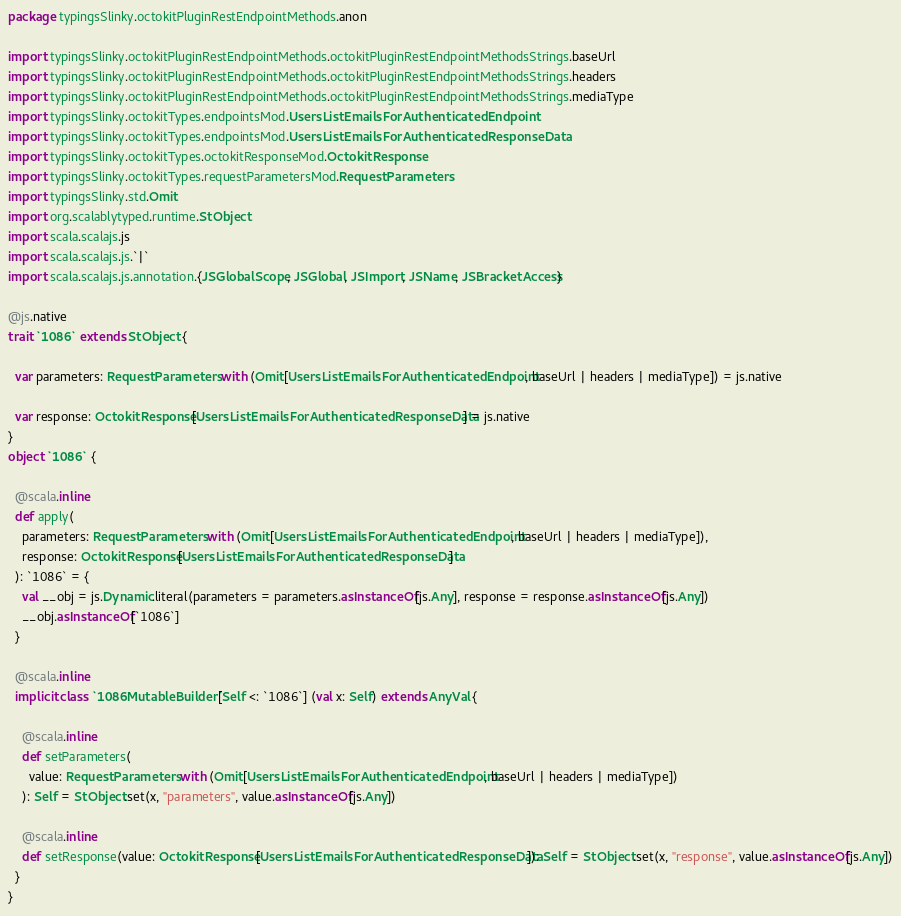Convert code to text. <code><loc_0><loc_0><loc_500><loc_500><_Scala_>package typingsSlinky.octokitPluginRestEndpointMethods.anon

import typingsSlinky.octokitPluginRestEndpointMethods.octokitPluginRestEndpointMethodsStrings.baseUrl
import typingsSlinky.octokitPluginRestEndpointMethods.octokitPluginRestEndpointMethodsStrings.headers
import typingsSlinky.octokitPluginRestEndpointMethods.octokitPluginRestEndpointMethodsStrings.mediaType
import typingsSlinky.octokitTypes.endpointsMod.UsersListEmailsForAuthenticatedEndpoint
import typingsSlinky.octokitTypes.endpointsMod.UsersListEmailsForAuthenticatedResponseData
import typingsSlinky.octokitTypes.octokitResponseMod.OctokitResponse
import typingsSlinky.octokitTypes.requestParametersMod.RequestParameters
import typingsSlinky.std.Omit
import org.scalablytyped.runtime.StObject
import scala.scalajs.js
import scala.scalajs.js.`|`
import scala.scalajs.js.annotation.{JSGlobalScope, JSGlobal, JSImport, JSName, JSBracketAccess}

@js.native
trait `1086` extends StObject {
  
  var parameters: RequestParameters with (Omit[UsersListEmailsForAuthenticatedEndpoint, baseUrl | headers | mediaType]) = js.native
  
  var response: OctokitResponse[UsersListEmailsForAuthenticatedResponseData] = js.native
}
object `1086` {
  
  @scala.inline
  def apply(
    parameters: RequestParameters with (Omit[UsersListEmailsForAuthenticatedEndpoint, baseUrl | headers | mediaType]),
    response: OctokitResponse[UsersListEmailsForAuthenticatedResponseData]
  ): `1086` = {
    val __obj = js.Dynamic.literal(parameters = parameters.asInstanceOf[js.Any], response = response.asInstanceOf[js.Any])
    __obj.asInstanceOf[`1086`]
  }
  
  @scala.inline
  implicit class `1086MutableBuilder`[Self <: `1086`] (val x: Self) extends AnyVal {
    
    @scala.inline
    def setParameters(
      value: RequestParameters with (Omit[UsersListEmailsForAuthenticatedEndpoint, baseUrl | headers | mediaType])
    ): Self = StObject.set(x, "parameters", value.asInstanceOf[js.Any])
    
    @scala.inline
    def setResponse(value: OctokitResponse[UsersListEmailsForAuthenticatedResponseData]): Self = StObject.set(x, "response", value.asInstanceOf[js.Any])
  }
}
</code> 